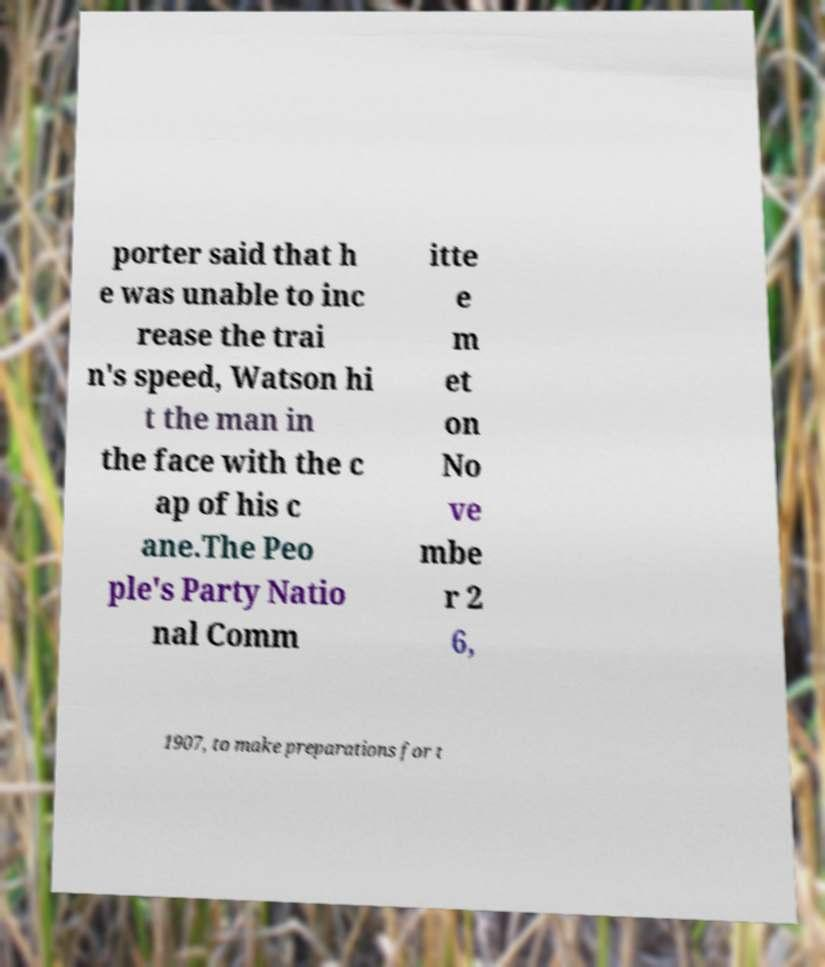There's text embedded in this image that I need extracted. Can you transcribe it verbatim? porter said that h e was unable to inc rease the trai n's speed, Watson hi t the man in the face with the c ap of his c ane.The Peo ple's Party Natio nal Comm itte e m et on No ve mbe r 2 6, 1907, to make preparations for t 